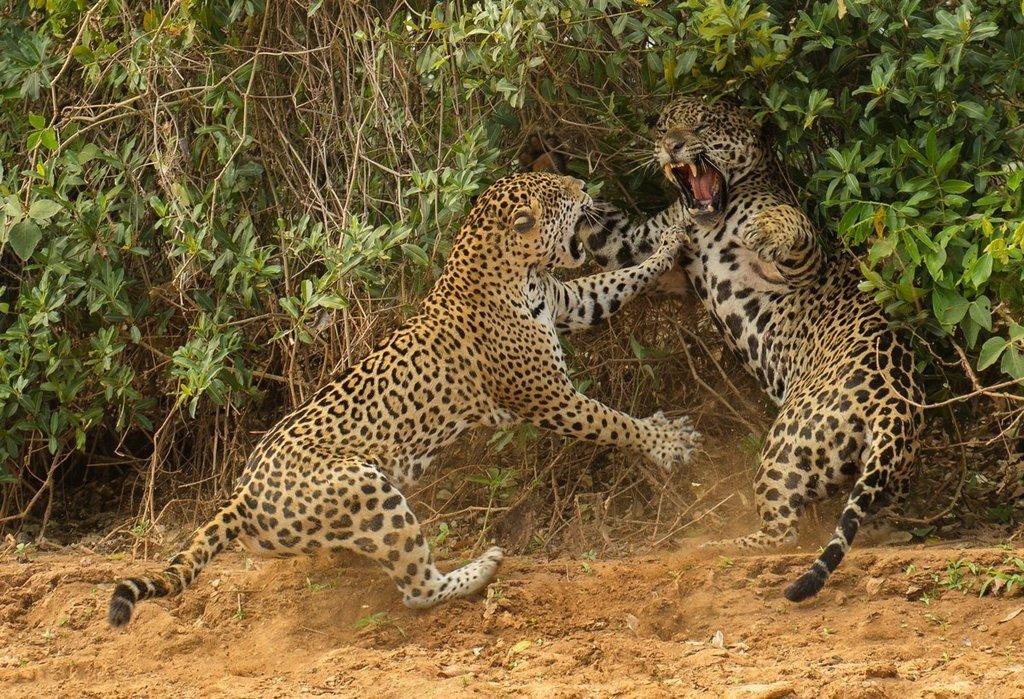How many animals are present in the image? There are 2 animals in the image. What are the animals doing in the image? The animals are fighting with each other. Where are the animals located in the image? The animals are on the ground. What type of natural environment is depicted in the image? There are trees surrounding the area and plants in the image, indicating a natural environment. What type of balls are being used by the animals in the image? There are no balls present in the image; the animals are fighting with each other. What is the cook preparing on the stove in the image? There is no cook or stove present in the image; it features two animals fighting in a natural environment. 